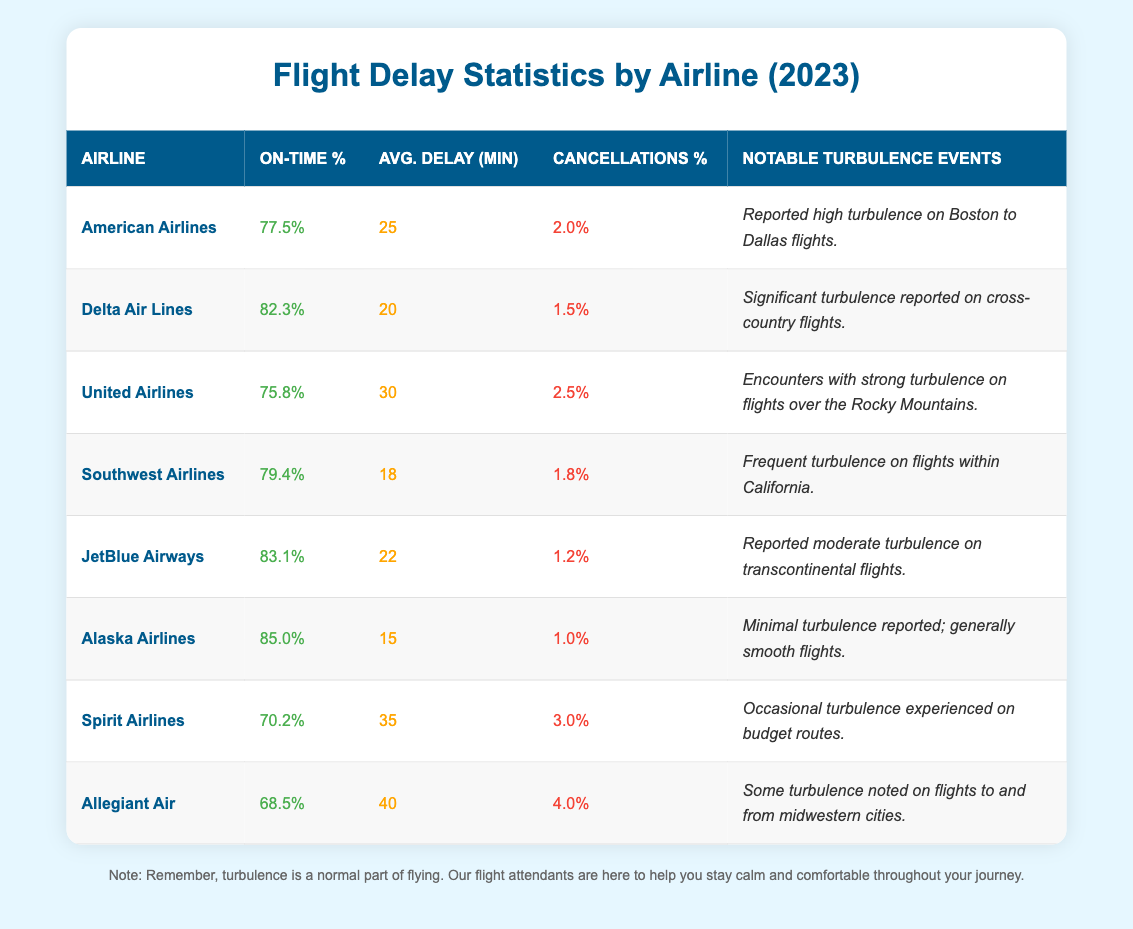What is the on-time percentage for Delta Air Lines? According to the table, the on-time percentage for Delta Air Lines is found in the second row of the table under the "On-Time %" column, which indicates 82.3%.
Answer: 82.3% Which airline has the highest on-time percentage? By reviewing the "On-Time %" column for all airlines in the table, Alaska Airlines has the highest on-time percentage at 85.0%.
Answer: Alaska Airlines What is the average delay time for Spirit Airlines? In the table, the average delay time for Spirit Airlines is located in the "Avg. Delay (min)" column, where it shows a value of 35 minutes.
Answer: 35 minutes How many airlines have an on-time percentage greater than 80%? From the data in the table, I can count the airlines with on-time percentages above 80%, which are Delta Air Lines (82.3%), JetBlue Airways (83.1%), and Alaska Airlines (85.0%). That's a total of 3 airlines.
Answer: 3 What is the average cancellation percentage for all airlines listed? To find the average cancellation percentage, sum the cancellations percentages of all airlines (2.0 + 1.5 + 2.5 + 1.8 + 1.2 + 1.0 + 3.0 + 4.0 = 17.0) and divide by the number of airlines (8). Therefore, the average is 17.0/8 = 2.125%.
Answer: 2.125% Is there any airline with a cancellation percentage higher than 3%? Looking at the "Cancellations %" column in the table, I see that Allegiant Air (4.0%) and Spirit Airlines (3.0%) have cancellation percentages that indicate Allegiant Air has a number greater than 3%.
Answer: Yes Which airline experienced the least notable turbulence? By reviewing the "Notable Turbulence Events" column in the table, Alaska Airlines mentions minimal turbulence reported, thus indicating it experienced the least notable turbulence among the listed airlines.
Answer: Alaska Airlines What is the difference in average delay minutes between American Airlines and JetBlue Airways? The average delay time for American Airlines is 25 minutes and for JetBlue Airways it is 22 minutes. The difference is calculated by subtracting 22 from 25, yielding 3 minutes.
Answer: 3 minutes Which airline has the highest average delay time? I can examine the "Avg. Delay (min)" column to find which airline has the highest value. Allegiant Air has an average delay time of 40 minutes, the highest among all listed airlines.
Answer: Allegiant Air Has any airline reported significant turbulence during flights? The "Notable Turbulence Events" column shows that both Delta Air Lines and United Airlines reported significant turbulence, confirming that there are airlines that have experienced this phenomenon.
Answer: Yes What percentage of delays does Southwest Airlines have compared to Spirit Airlines? Southwest Airlines' average delay minutes are 18, while Spirit Airlines' are 35. To compare, Spirit Airlines has 35 - 18 = 17 more minutes of delay on average than Southwest Airlines.
Answer: 17 minutes more 